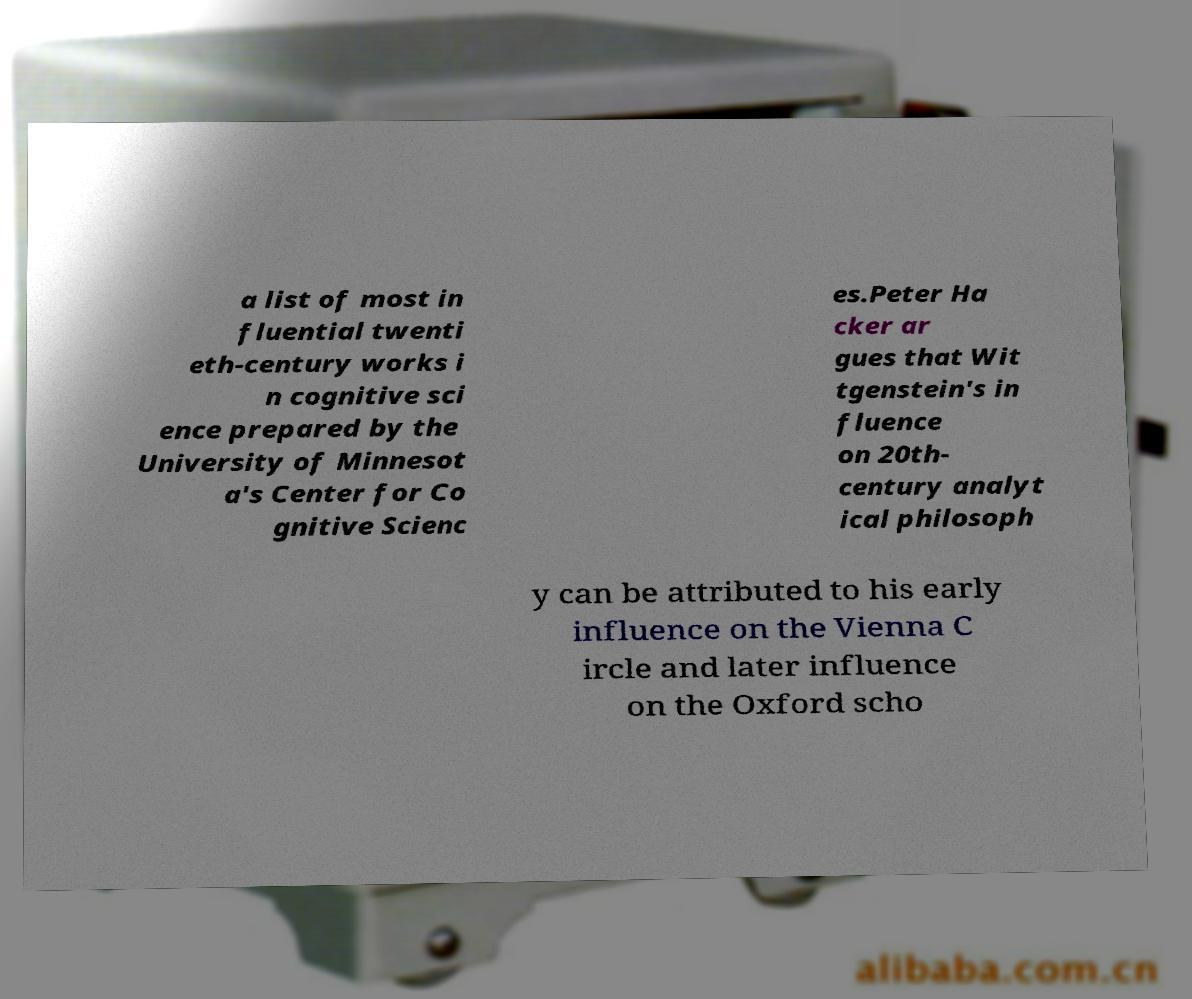Can you accurately transcribe the text from the provided image for me? a list of most in fluential twenti eth-century works i n cognitive sci ence prepared by the University of Minnesot a's Center for Co gnitive Scienc es.Peter Ha cker ar gues that Wit tgenstein's in fluence on 20th- century analyt ical philosoph y can be attributed to his early influence on the Vienna C ircle and later influence on the Oxford scho 